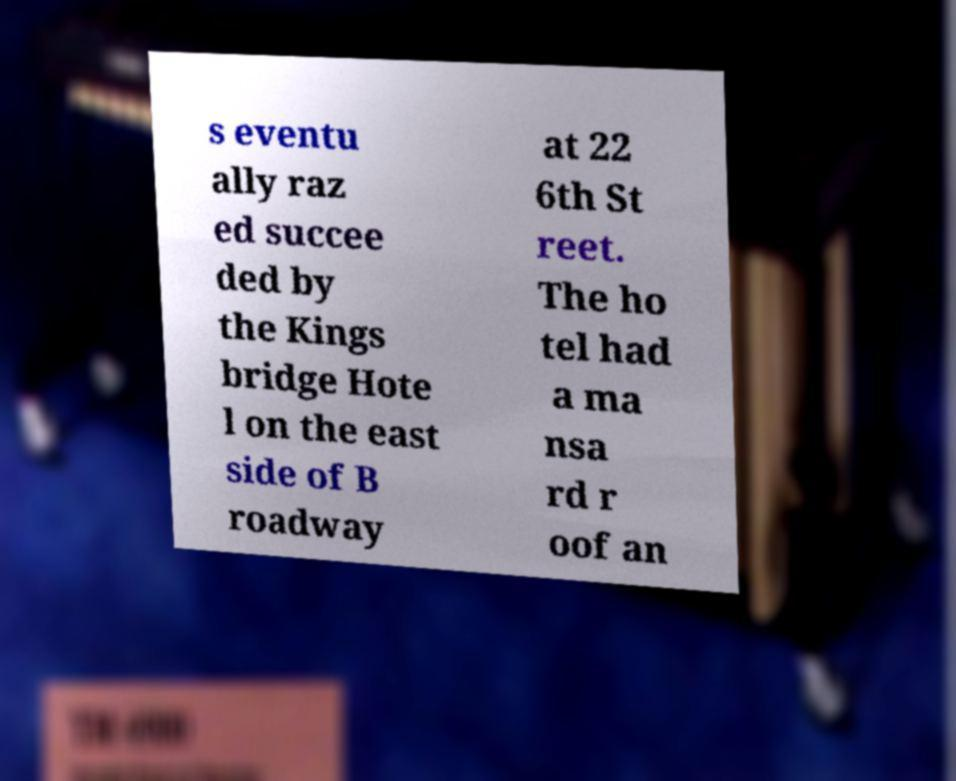There's text embedded in this image that I need extracted. Can you transcribe it verbatim? s eventu ally raz ed succee ded by the Kings bridge Hote l on the east side of B roadway at 22 6th St reet. The ho tel had a ma nsa rd r oof an 